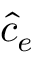<formula> <loc_0><loc_0><loc_500><loc_500>\hat { c } _ { e }</formula> 